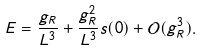<formula> <loc_0><loc_0><loc_500><loc_500>E = \frac { g _ { R } } { L ^ { 3 } } + \frac { g _ { R } ^ { 2 } } { L ^ { 3 } } s ( 0 ) + \mathcal { O } ( g _ { R } ^ { 3 } ) .</formula> 